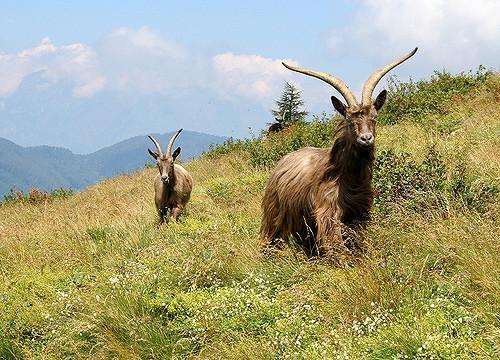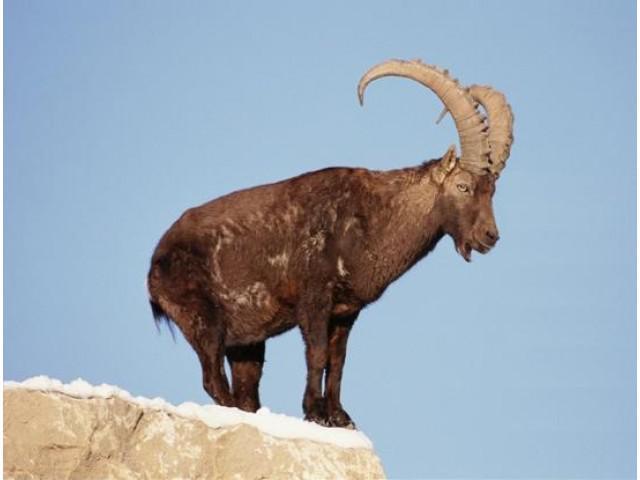The first image is the image on the left, the second image is the image on the right. Examine the images to the left and right. Is the description "There are at least three mountain goats." accurate? Answer yes or no. Yes. The first image is the image on the left, the second image is the image on the right. Assess this claim about the two images: "One big horn sheep is facing left.". Correct or not? Answer yes or no. No. 